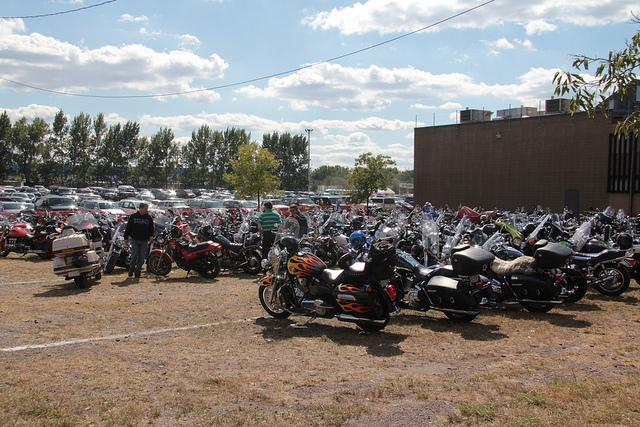The glare from the sun is distracting for drivers by reflecting off of what surface? glass 